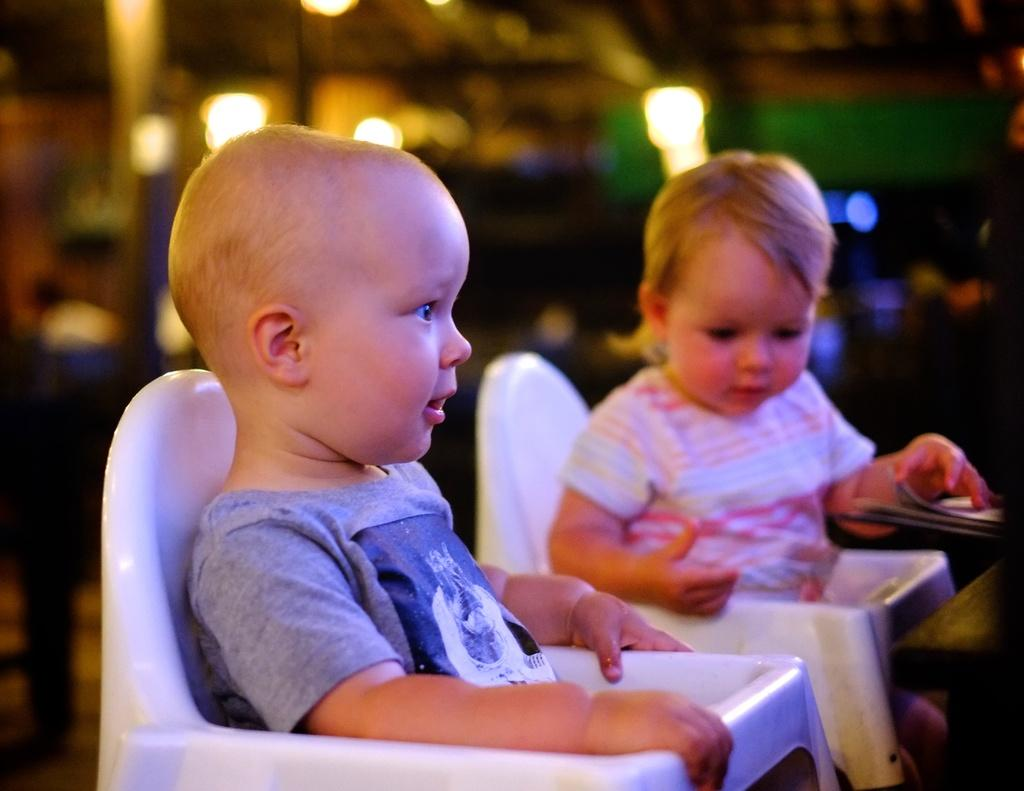What objects are in the foreground of the picture? There are chairs in the foreground of the picture. What are the chairs being used for? Two kids are sitting in the chairs. How would you describe the background of the image? The background of the image is blurred. What can be seen in the background despite the blur? Lights are visible in the background. How many sisters are present in the image? There is no mention of sisters in the image, so it cannot be determined from the facts provided. What type of chickens can be seen in the image? There are no chickens present in the image. 